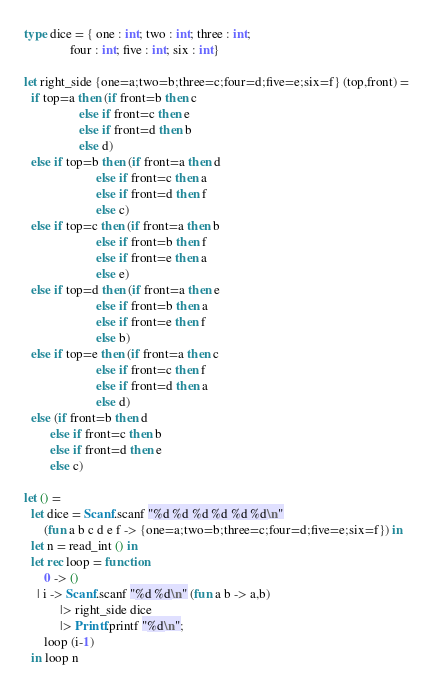Convert code to text. <code><loc_0><loc_0><loc_500><loc_500><_OCaml_>type dice = { one : int; two : int; three : int;
              four : int; five : int; six : int}

let right_side {one=a;two=b;three=c;four=d;five=e;six=f} (top,front) =
  if top=a then (if front=b then c
                 else if front=c then e
                 else if front=d then b
                 else d)
  else if top=b then (if front=a then d
                      else if front=c then a
                      else if front=d then f
                      else c)
  else if top=c then (if front=a then b
                      else if front=b then f
                      else if front=e then a
                      else e)
  else if top=d then (if front=a then e
                      else if front=b then a
                      else if front=e then f
                      else b)
  else if top=e then (if front=a then c
                      else if front=c then f
                      else if front=d then a
                      else d)
  else (if front=b then d
        else if front=c then b
        else if front=d then e
        else c)

let () =
  let dice = Scanf.scanf "%d %d %d %d %d %d\n"
      (fun a b c d e f -> {one=a;two=b;three=c;four=d;five=e;six=f}) in
  let n = read_int () in
  let rec loop = function
      0 -> ()
    | i -> Scanf.scanf "%d %d\n" (fun a b -> a,b)
           |> right_side dice
           |> Printf.printf "%d\n";
      loop (i-1)
  in loop n</code> 